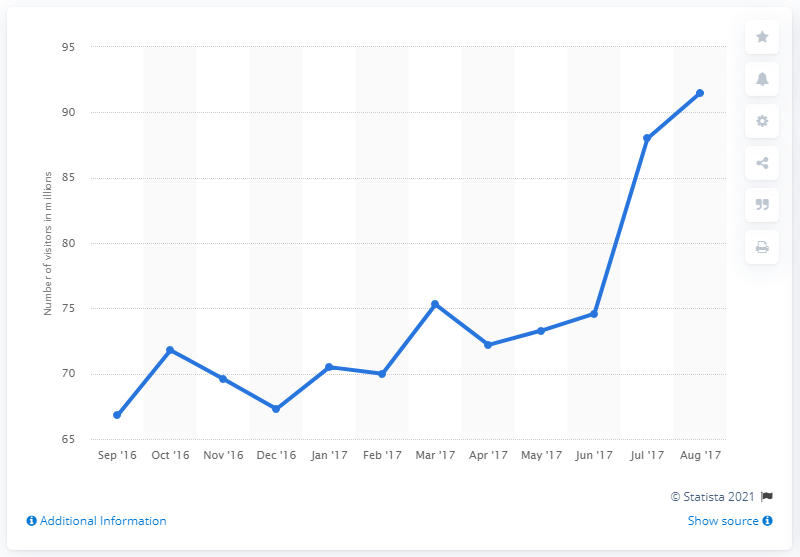Draw attention to some important aspects in this diagram. As of August 2017, Pinterest had 91.5 unique visitors. 